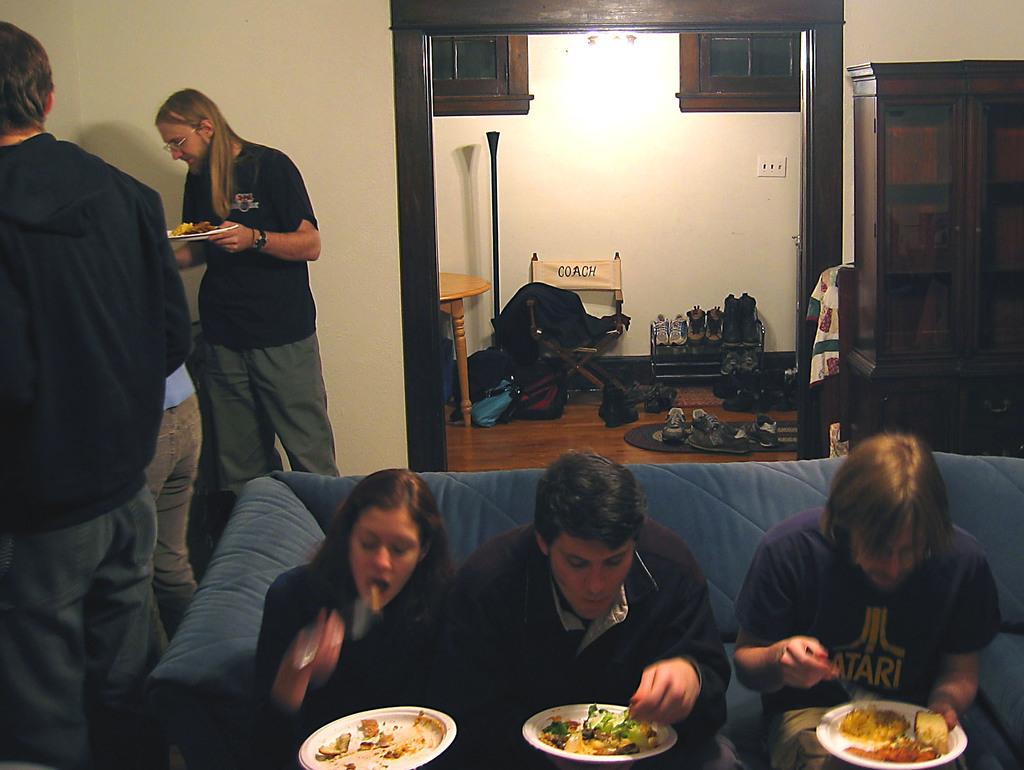Please provide a concise description of this image. There are three persons sitting in a sofa and eating and there are few people beside them and there are also group of shoes in the background. 